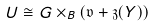<formula> <loc_0><loc_0><loc_500><loc_500>U \cong G \times _ { B } ( \mathfrak v + \mathfrak z ( Y ) )</formula> 